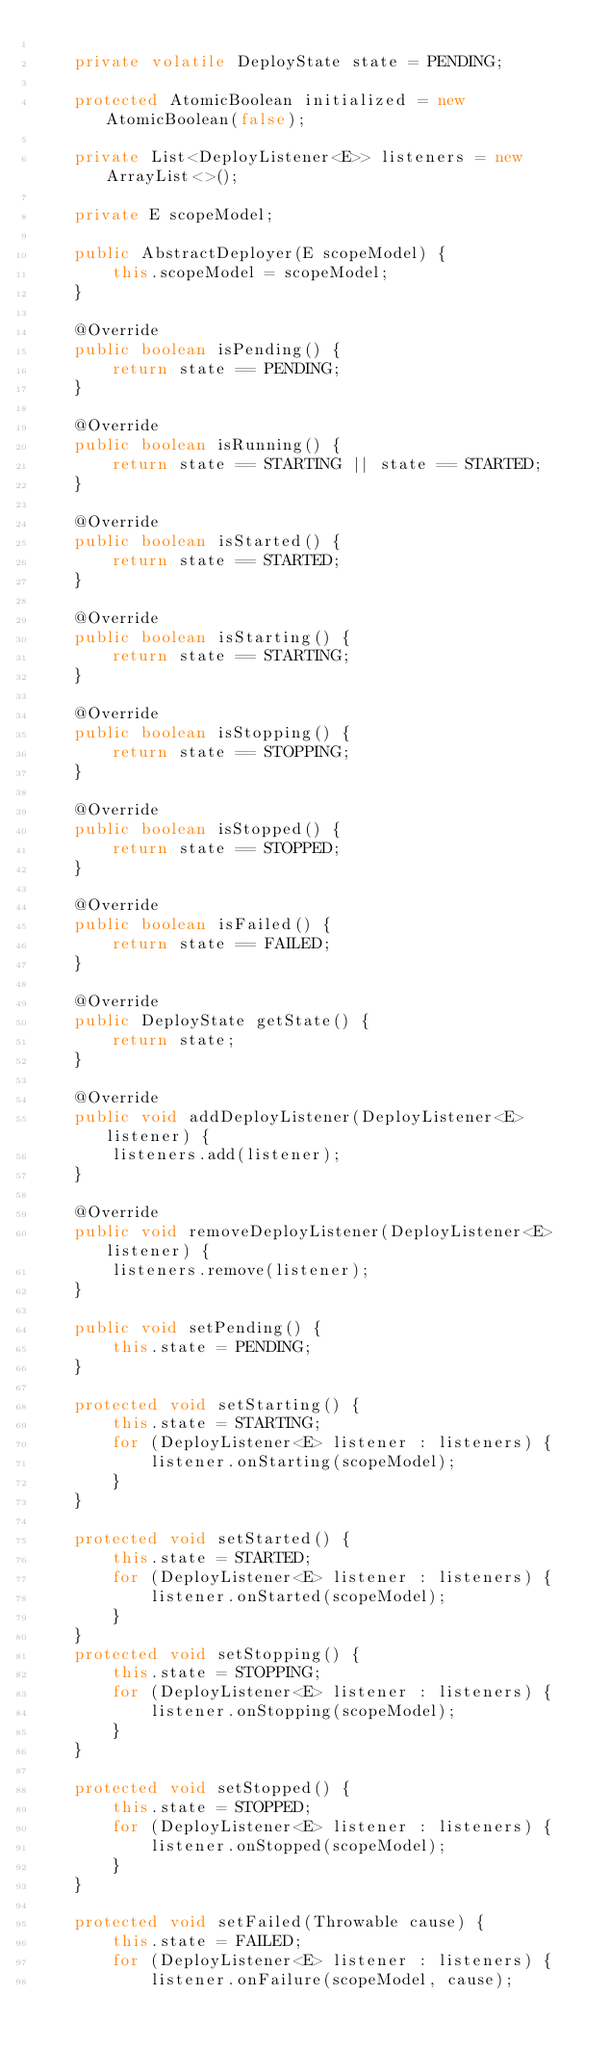Convert code to text. <code><loc_0><loc_0><loc_500><loc_500><_Java_>
    private volatile DeployState state = PENDING;

    protected AtomicBoolean initialized = new AtomicBoolean(false);

    private List<DeployListener<E>> listeners = new ArrayList<>();

    private E scopeModel;

    public AbstractDeployer(E scopeModel) {
        this.scopeModel = scopeModel;
    }

    @Override
    public boolean isPending() {
        return state == PENDING;
    }

    @Override
    public boolean isRunning() {
        return state == STARTING || state == STARTED;
    }

    @Override
    public boolean isStarted() {
        return state == STARTED;
    }

    @Override
    public boolean isStarting() {
        return state == STARTING;
    }

    @Override
    public boolean isStopping() {
        return state == STOPPING;
    }

    @Override
    public boolean isStopped() {
        return state == STOPPED;
    }

    @Override
    public boolean isFailed() {
        return state == FAILED;
    }

    @Override
    public DeployState getState() {
        return state;
    }

    @Override
    public void addDeployListener(DeployListener<E> listener) {
        listeners.add(listener);
    }

    @Override
    public void removeDeployListener(DeployListener<E> listener) {
        listeners.remove(listener);
    }

    public void setPending() {
        this.state = PENDING;
    }

    protected void setStarting() {
        this.state = STARTING;
        for (DeployListener<E> listener : listeners) {
            listener.onStarting(scopeModel);
        }
    }

    protected void setStarted() {
        this.state = STARTED;
        for (DeployListener<E> listener : listeners) {
            listener.onStarted(scopeModel);
        }
    }
    protected void setStopping() {
        this.state = STOPPING;
        for (DeployListener<E> listener : listeners) {
            listener.onStopping(scopeModel);
        }
    }

    protected void setStopped() {
        this.state = STOPPED;
        for (DeployListener<E> listener : listeners) {
            listener.onStopped(scopeModel);
        }
    }

    protected void setFailed(Throwable cause) {
        this.state = FAILED;
        for (DeployListener<E> listener : listeners) {
            listener.onFailure(scopeModel, cause);</code> 